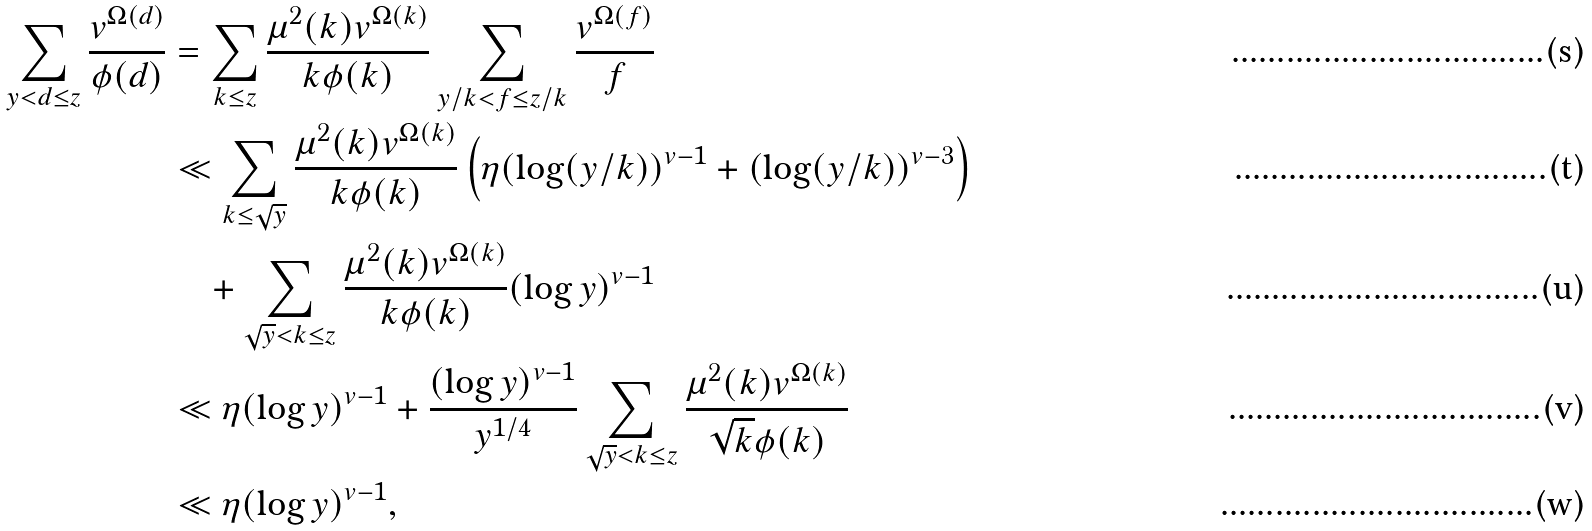<formula> <loc_0><loc_0><loc_500><loc_500>\sum _ { y < d \leq z } \frac { v ^ { \Omega ( d ) } } { \phi ( d ) } & = \sum _ { k \leq z } \frac { \mu ^ { 2 } ( k ) v ^ { \Omega ( k ) } } { k \phi ( k ) } \sum _ { y / k < f \leq z / k } \frac { v ^ { \Omega ( f ) } } f \\ & \ll \sum _ { k \leq \sqrt { y } } \frac { \mu ^ { 2 } ( k ) v ^ { \Omega ( k ) } } { k \phi ( k ) } \left ( \eta ( \log ( y / k ) ) ^ { v - 1 } + ( \log ( y / k ) ) ^ { v - 3 } \right ) \\ & \quad + \sum _ { \sqrt { y } < k \leq z } \frac { \mu ^ { 2 } ( k ) v ^ { \Omega ( k ) } } { k \phi ( k ) } ( \log y ) ^ { v - 1 } \\ & \ll \eta ( \log y ) ^ { v - 1 } + \frac { ( \log y ) ^ { v - 1 } } { y ^ { 1 / 4 } } \sum _ { \sqrt { y } < k \leq z } \frac { \mu ^ { 2 } ( k ) v ^ { \Omega ( k ) } } { \sqrt { k } \phi ( k ) } \\ & \ll \eta ( \log y ) ^ { v - 1 } ,</formula> 